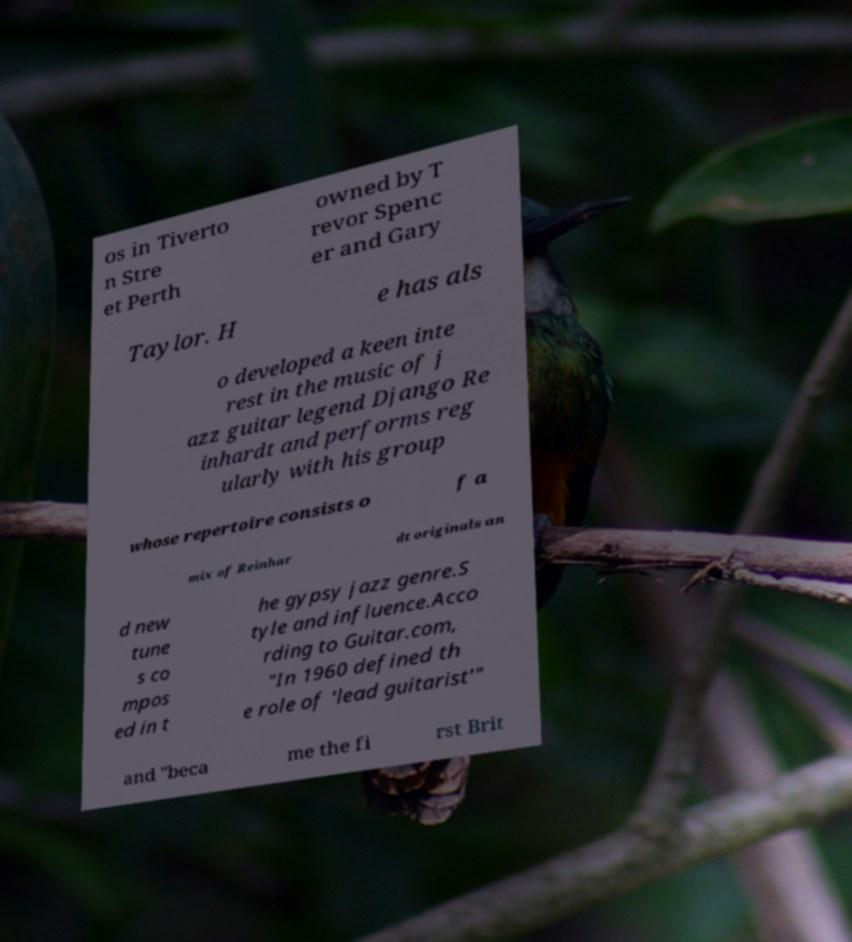Can you accurately transcribe the text from the provided image for me? os in Tiverto n Stre et Perth owned by T revor Spenc er and Gary Taylor. H e has als o developed a keen inte rest in the music of j azz guitar legend Django Re inhardt and performs reg ularly with his group whose repertoire consists o f a mix of Reinhar dt originals an d new tune s co mpos ed in t he gypsy jazz genre.S tyle and influence.Acco rding to Guitar.com, "In 1960 defined th e role of 'lead guitarist'" and "beca me the fi rst Brit 